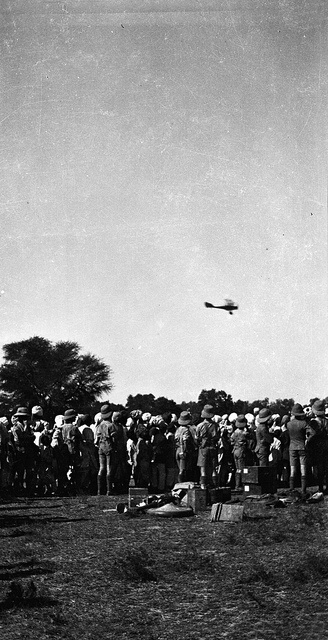Describe the objects in this image and their specific colors. I can see people in gray, black, lightgray, and darkgray tones, people in gray, black, darkgray, and gainsboro tones, people in gray, black, darkgray, and lightgray tones, people in gray, black, darkgray, and lightgray tones, and people in gray, black, darkgray, and lightgray tones in this image. 